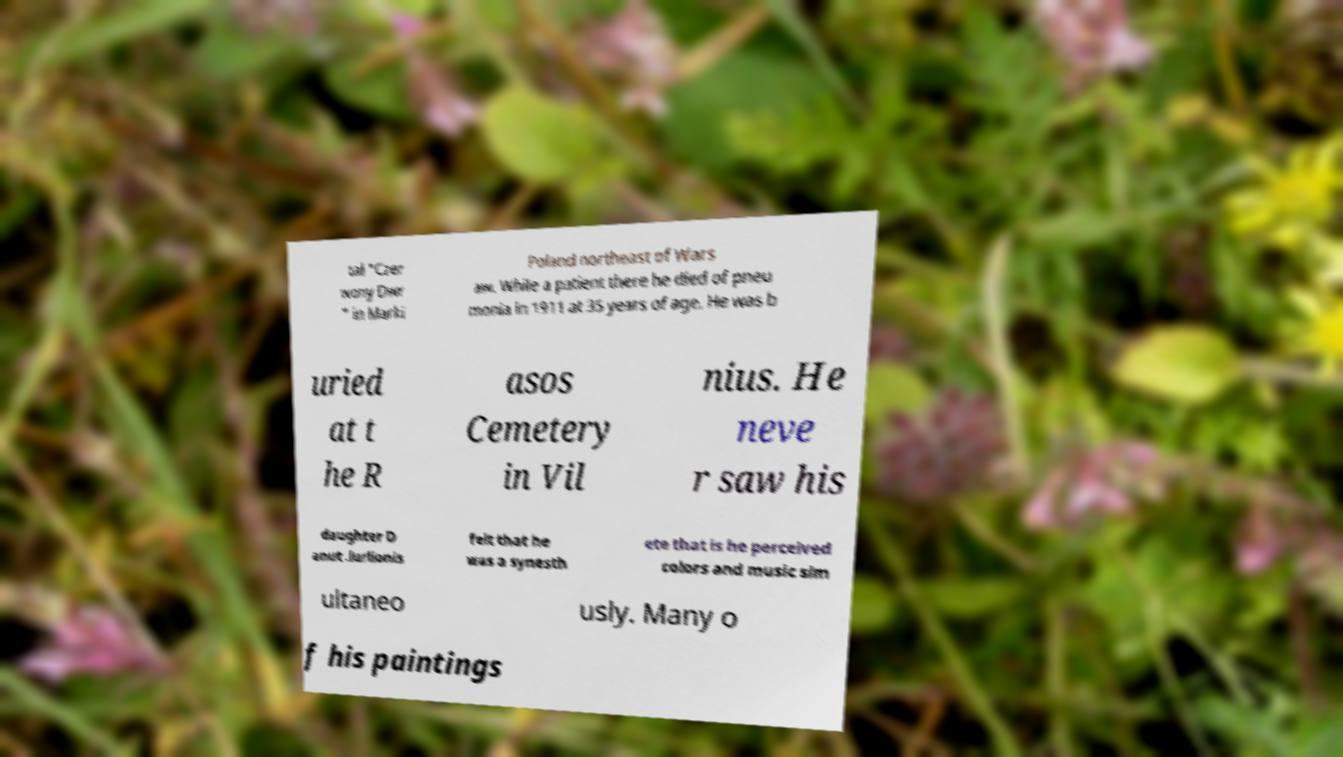Can you read and provide the text displayed in the image?This photo seems to have some interesting text. Can you extract and type it out for me? tal "Czer wony Dwr " in Marki Poland northeast of Wars aw. While a patient there he died of pneu monia in 1911 at 35 years of age. He was b uried at t he R asos Cemetery in Vil nius. He neve r saw his daughter D anut .iurlionis felt that he was a synesth ete that is he perceived colors and music sim ultaneo usly. Many o f his paintings 